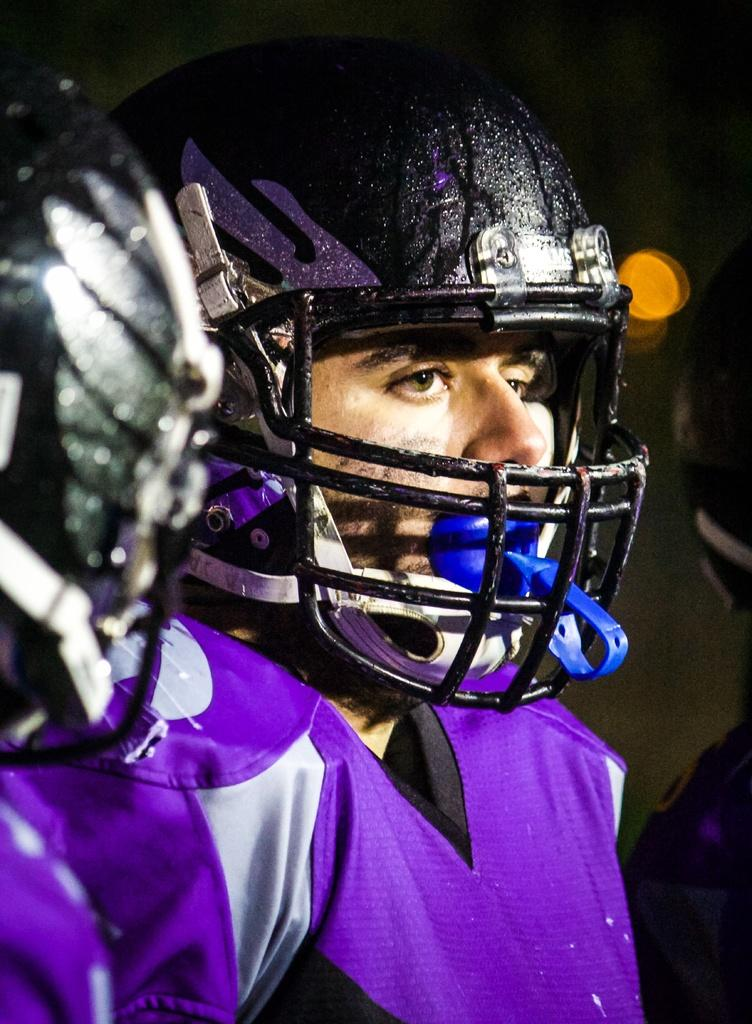What can be seen in the image? There is a person in the image. What is the person wearing on their upper body? The person is wearing a purple shirt. What type of protective gear is the person wearing? The person is wearing a helmet. What riddle is the person trying to solve in the image? There is no riddle present in the image; it simply shows a person wearing a purple shirt and a helmet. 